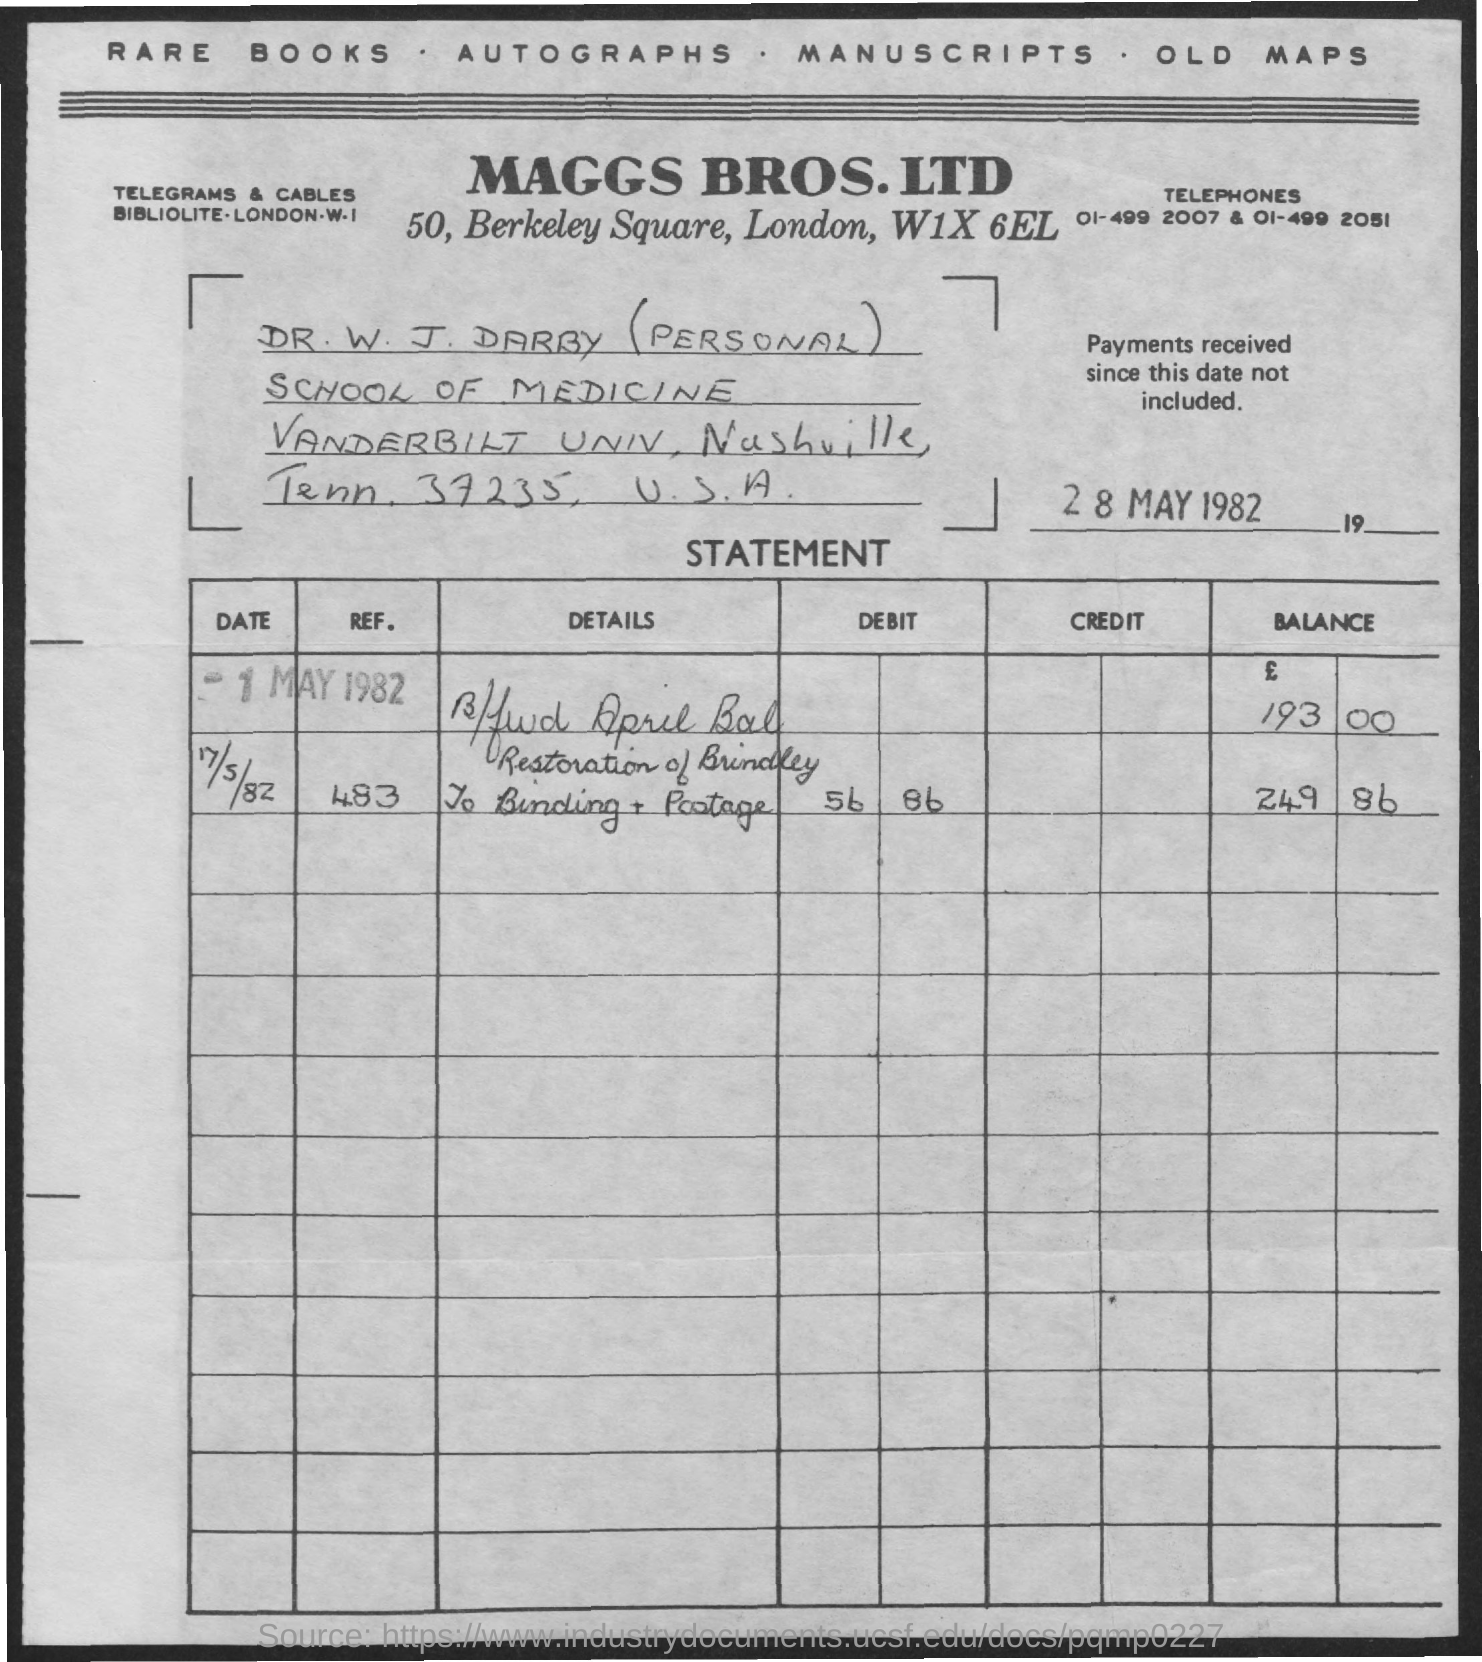Highlight a few significant elements in this photo. Maggs Bros. Ltd. is located in London. The document is dated as of May 28, 1982. 